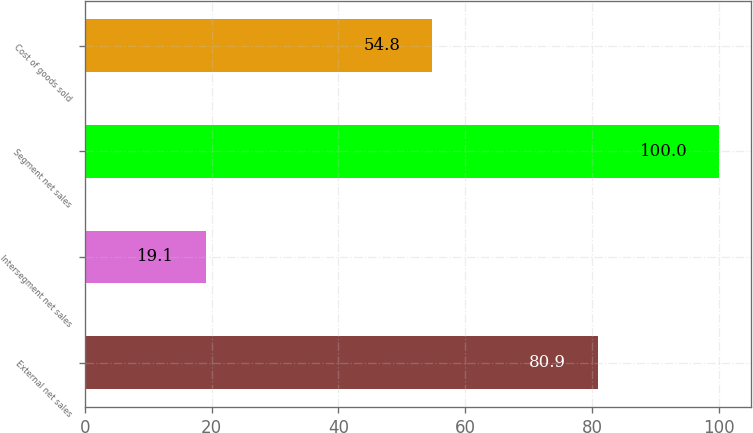<chart> <loc_0><loc_0><loc_500><loc_500><bar_chart><fcel>External net sales<fcel>Intersegment net sales<fcel>Segment net sales<fcel>Cost of goods sold<nl><fcel>80.9<fcel>19.1<fcel>100<fcel>54.8<nl></chart> 